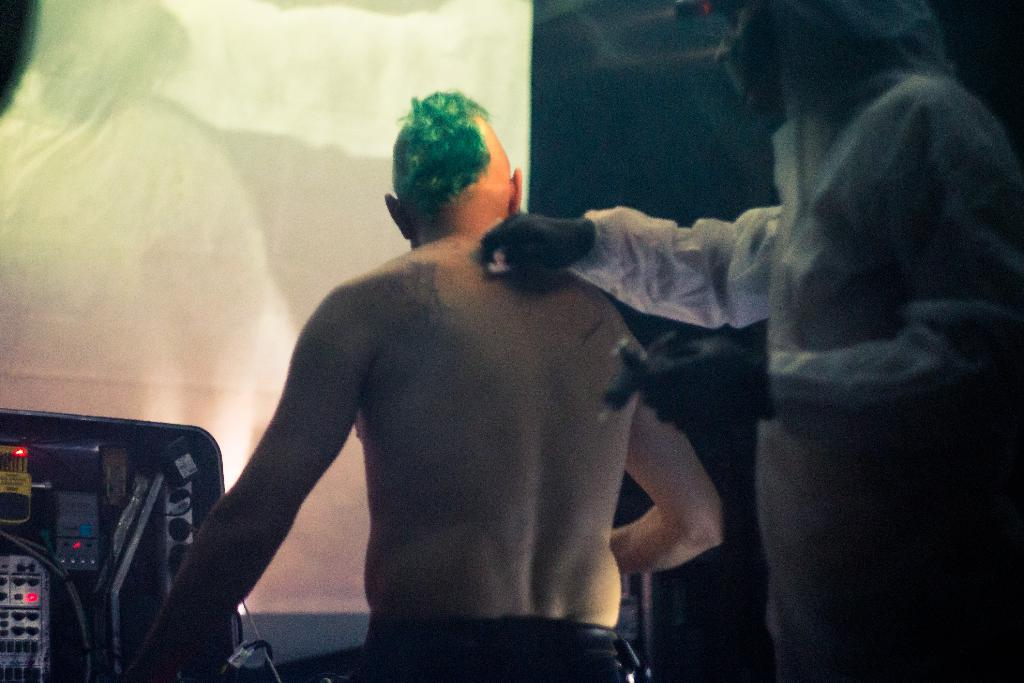What is located on the right side of the image? There is a person on the right side of the image. What is the position of the person in the center of the image? There is a person sitting in the center of the image. What can be seen on the left side of the image? There is a machine on the left side of the image. What is present in the background of the image? There is a curtain in the background of the image. What type of shirt is the committee wearing in the image? There is no committee present in the image, and therefore no one is wearing a shirt. What impulse can be seen driving the machine in the image? There is no impulse driving the machine in the image; it is stationary. 